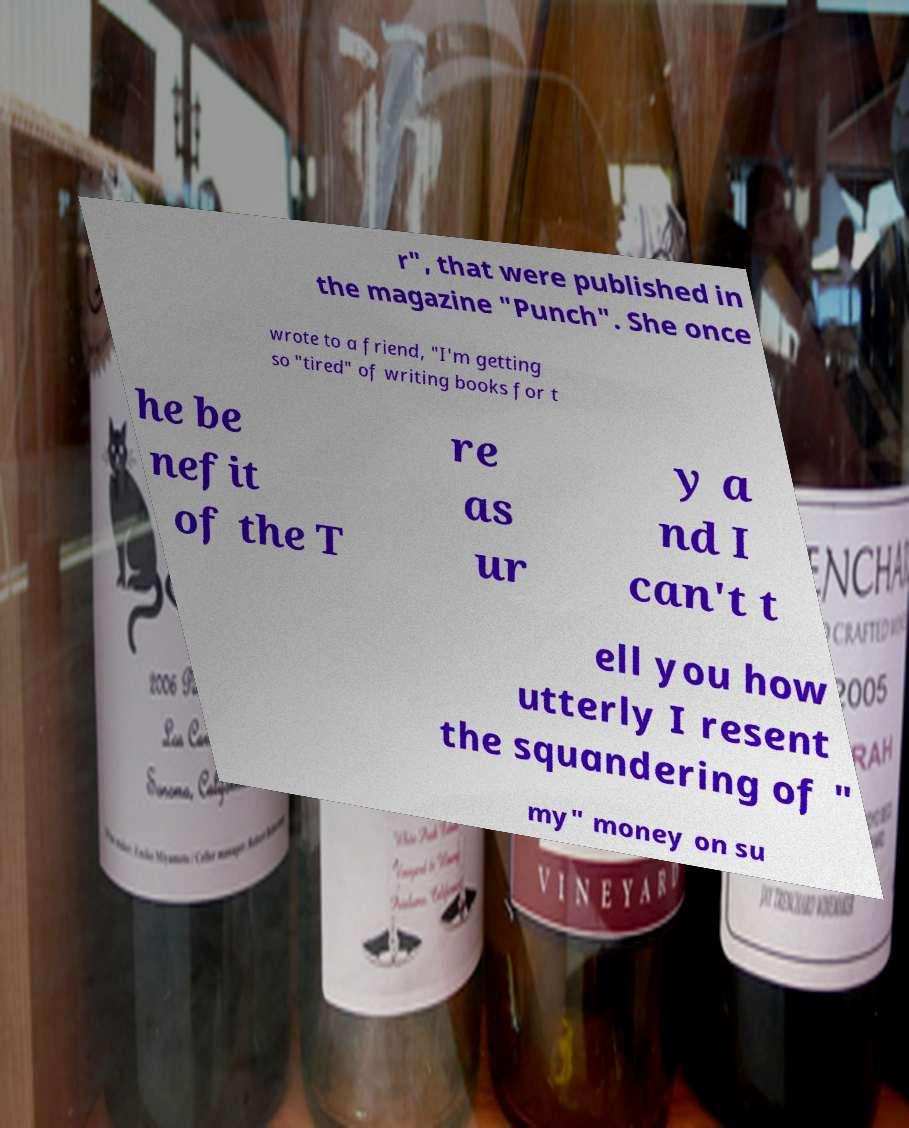Could you extract and type out the text from this image? r", that were published in the magazine "Punch". She once wrote to a friend, "I'm getting so "tired" of writing books for t he be nefit of the T re as ur y a nd I can't t ell you how utterly I resent the squandering of " my" money on su 